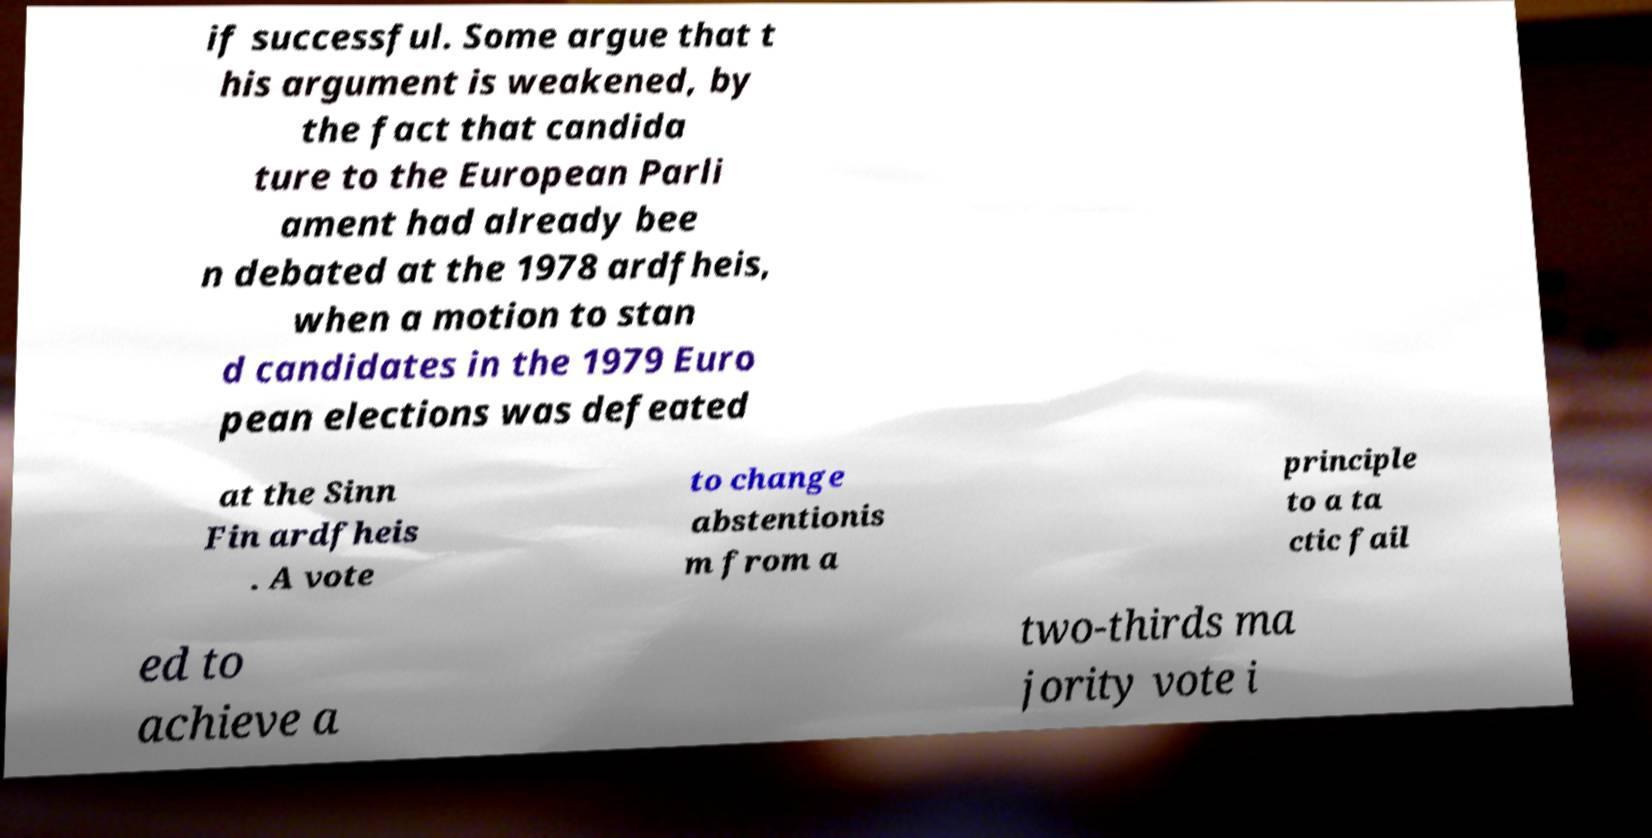Can you accurately transcribe the text from the provided image for me? if successful. Some argue that t his argument is weakened, by the fact that candida ture to the European Parli ament had already bee n debated at the 1978 ardfheis, when a motion to stan d candidates in the 1979 Euro pean elections was defeated at the Sinn Fin ardfheis . A vote to change abstentionis m from a principle to a ta ctic fail ed to achieve a two-thirds ma jority vote i 